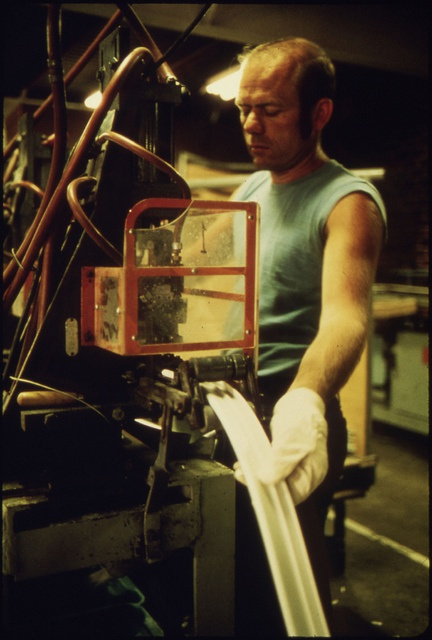Describe the objects in this image and their specific colors. I can see people in black, maroon, olive, and tan tones in this image. 